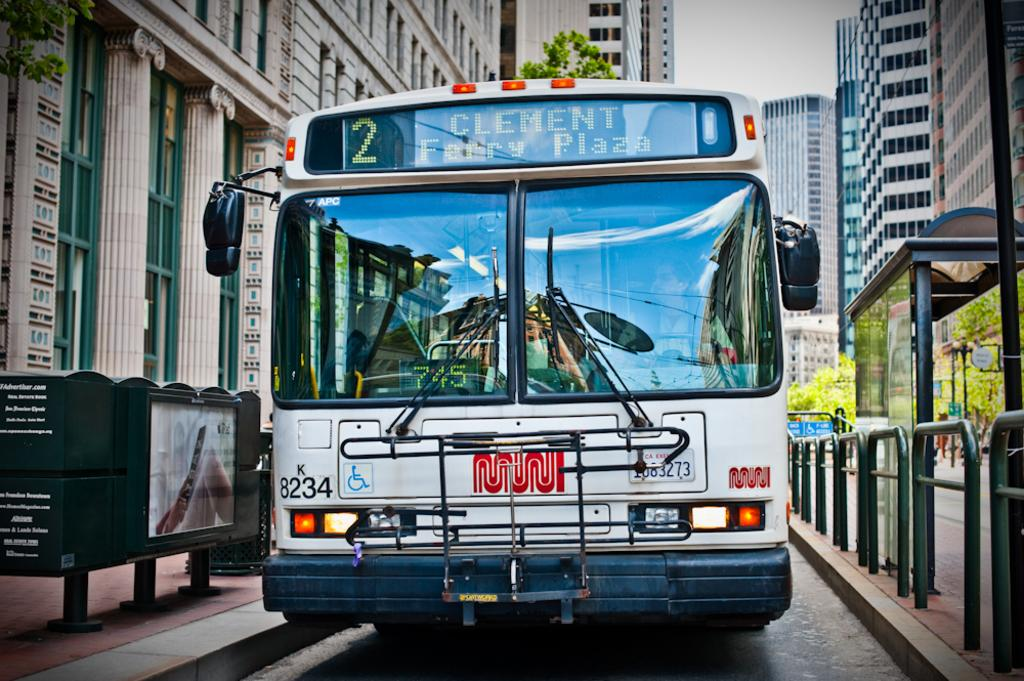What is the main subject of the image? The main subject of the image is a bus. Where is the bus located in relation to the bus bay? The bus is beside a bus bay. What can be seen in the background of the image? There are many tall buildings around the bus. What type of furniture is present in the image? There is no furniture present in the image; it features a bus beside a bus bay with tall buildings in the background. 